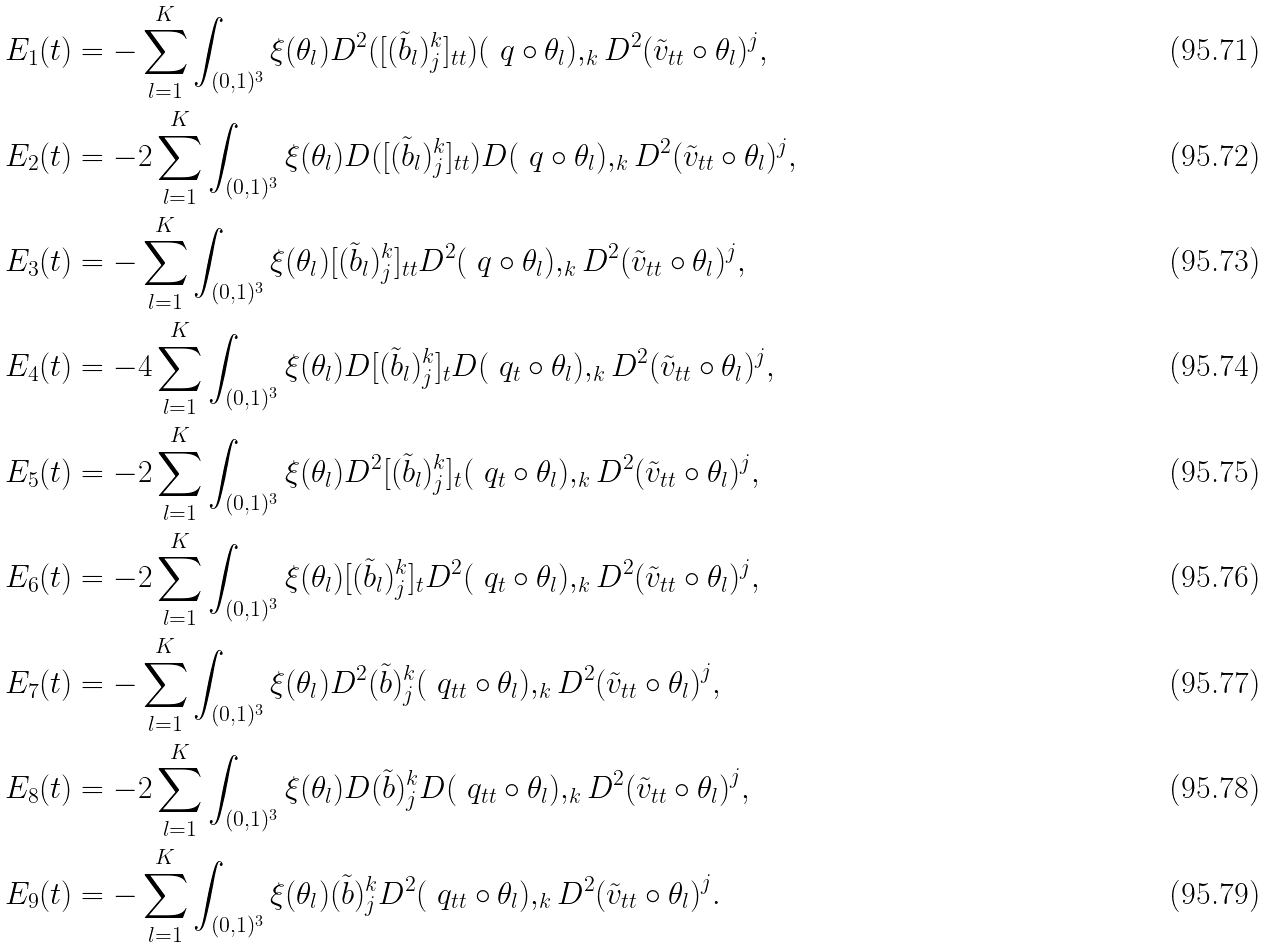<formula> <loc_0><loc_0><loc_500><loc_500>E _ { 1 } ( t ) & = - \sum _ { l = 1 } ^ { K } \int _ { ( 0 , 1 ) ^ { 3 } } \xi ( \theta _ { l } ) D ^ { 2 } ( [ ( \tilde { b } _ { l } ) _ { j } ^ { k } ] _ { t t } ) ( \ q \circ \theta _ { l } ) , _ { k } D ^ { 2 } ( { \tilde { v } } _ { t t } \circ \theta _ { l } ) ^ { j } , \\ E _ { 2 } ( t ) & = - 2 \sum _ { l = 1 } ^ { K } \int _ { ( 0 , 1 ) ^ { 3 } } \xi ( \theta _ { l } ) D ( [ ( \tilde { b } _ { l } ) _ { j } ^ { k } ] _ { t t } ) D ( \ q \circ \theta _ { l } ) , _ { k } D ^ { 2 } ( { \tilde { v } } _ { t t } \circ \theta _ { l } ) ^ { j } , \\ E _ { 3 } ( t ) & = - \sum _ { l = 1 } ^ { K } \int _ { ( 0 , 1 ) ^ { 3 } } \xi ( \theta _ { l } ) [ ( \tilde { b } _ { l } ) _ { j } ^ { k } ] _ { t t } D ^ { 2 } ( \ q \circ \theta _ { l } ) , _ { k } D ^ { 2 } ( { \tilde { v } } _ { t t } \circ \theta _ { l } ) ^ { j } , \\ E _ { 4 } ( t ) & = - 4 \sum _ { l = 1 } ^ { K } \int _ { ( 0 , 1 ) ^ { 3 } } \xi ( \theta _ { l } ) D [ ( \tilde { b } _ { l } ) _ { j } ^ { k } ] _ { t } D ( \ q _ { t } \circ \theta _ { l } ) , _ { k } D ^ { 2 } ( { \tilde { v } } _ { t t } \circ \theta _ { l } ) ^ { j } , \\ E _ { 5 } ( t ) & = - 2 \sum _ { l = 1 } ^ { K } \int _ { ( 0 , 1 ) ^ { 3 } } \xi ( \theta _ { l } ) D ^ { 2 } [ ( \tilde { b } _ { l } ) _ { j } ^ { k } ] _ { t } ( \ q _ { t } \circ \theta _ { l } ) , _ { k } D ^ { 2 } ( { \tilde { v } } _ { t t } \circ \theta _ { l } ) ^ { j } , \\ E _ { 6 } ( t ) & = - 2 \sum _ { l = 1 } ^ { K } \int _ { ( 0 , 1 ) ^ { 3 } } \xi ( \theta _ { l } ) [ ( \tilde { b } _ { l } ) _ { j } ^ { k } ] _ { t } D ^ { 2 } ( \ q _ { t } \circ \theta _ { l } ) , _ { k } D ^ { 2 } ( { \tilde { v } } _ { t t } \circ \theta _ { l } ) ^ { j } , \\ E _ { 7 } ( t ) & = - \sum _ { l = 1 } ^ { K } \int _ { ( 0 , 1 ) ^ { 3 } } \xi ( \theta _ { l } ) D ^ { 2 } ( \tilde { b } ) _ { j } ^ { k } ( \ q _ { t t } \circ \theta _ { l } ) , _ { k } D ^ { 2 } { ( \tilde { v } _ { t t } \circ \theta _ { l } ) } ^ { j } , \\ E _ { 8 } ( t ) & = - 2 \sum _ { l = 1 } ^ { K } \int _ { ( 0 , 1 ) ^ { 3 } } \xi ( \theta _ { l } ) D ( \tilde { b } ) _ { j } ^ { k } D ( \ q _ { t t } \circ \theta _ { l } ) , _ { k } D ^ { 2 } { ( \tilde { v } _ { t t } \circ \theta _ { l } ) } ^ { j } , \\ E _ { 9 } ( t ) & = - \sum _ { l = 1 } ^ { K } \int _ { ( 0 , 1 ) ^ { 3 } } \xi ( \theta _ { l } ) ( \tilde { b } ) _ { j } ^ { k } D ^ { 2 } ( \ q _ { t t } \circ \theta _ { l } ) , _ { k } D ^ { 2 } { ( \tilde { v } _ { t t } \circ \theta _ { l } ) } ^ { j } .</formula> 